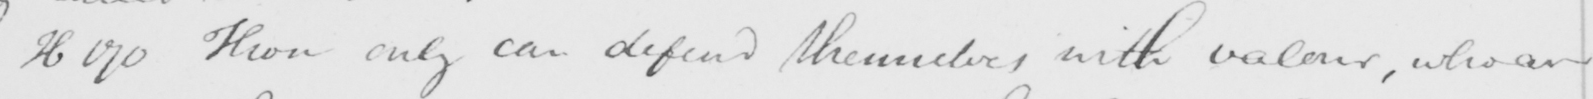What does this handwritten line say? H170 Those only can defend themselves with valeur , who are 